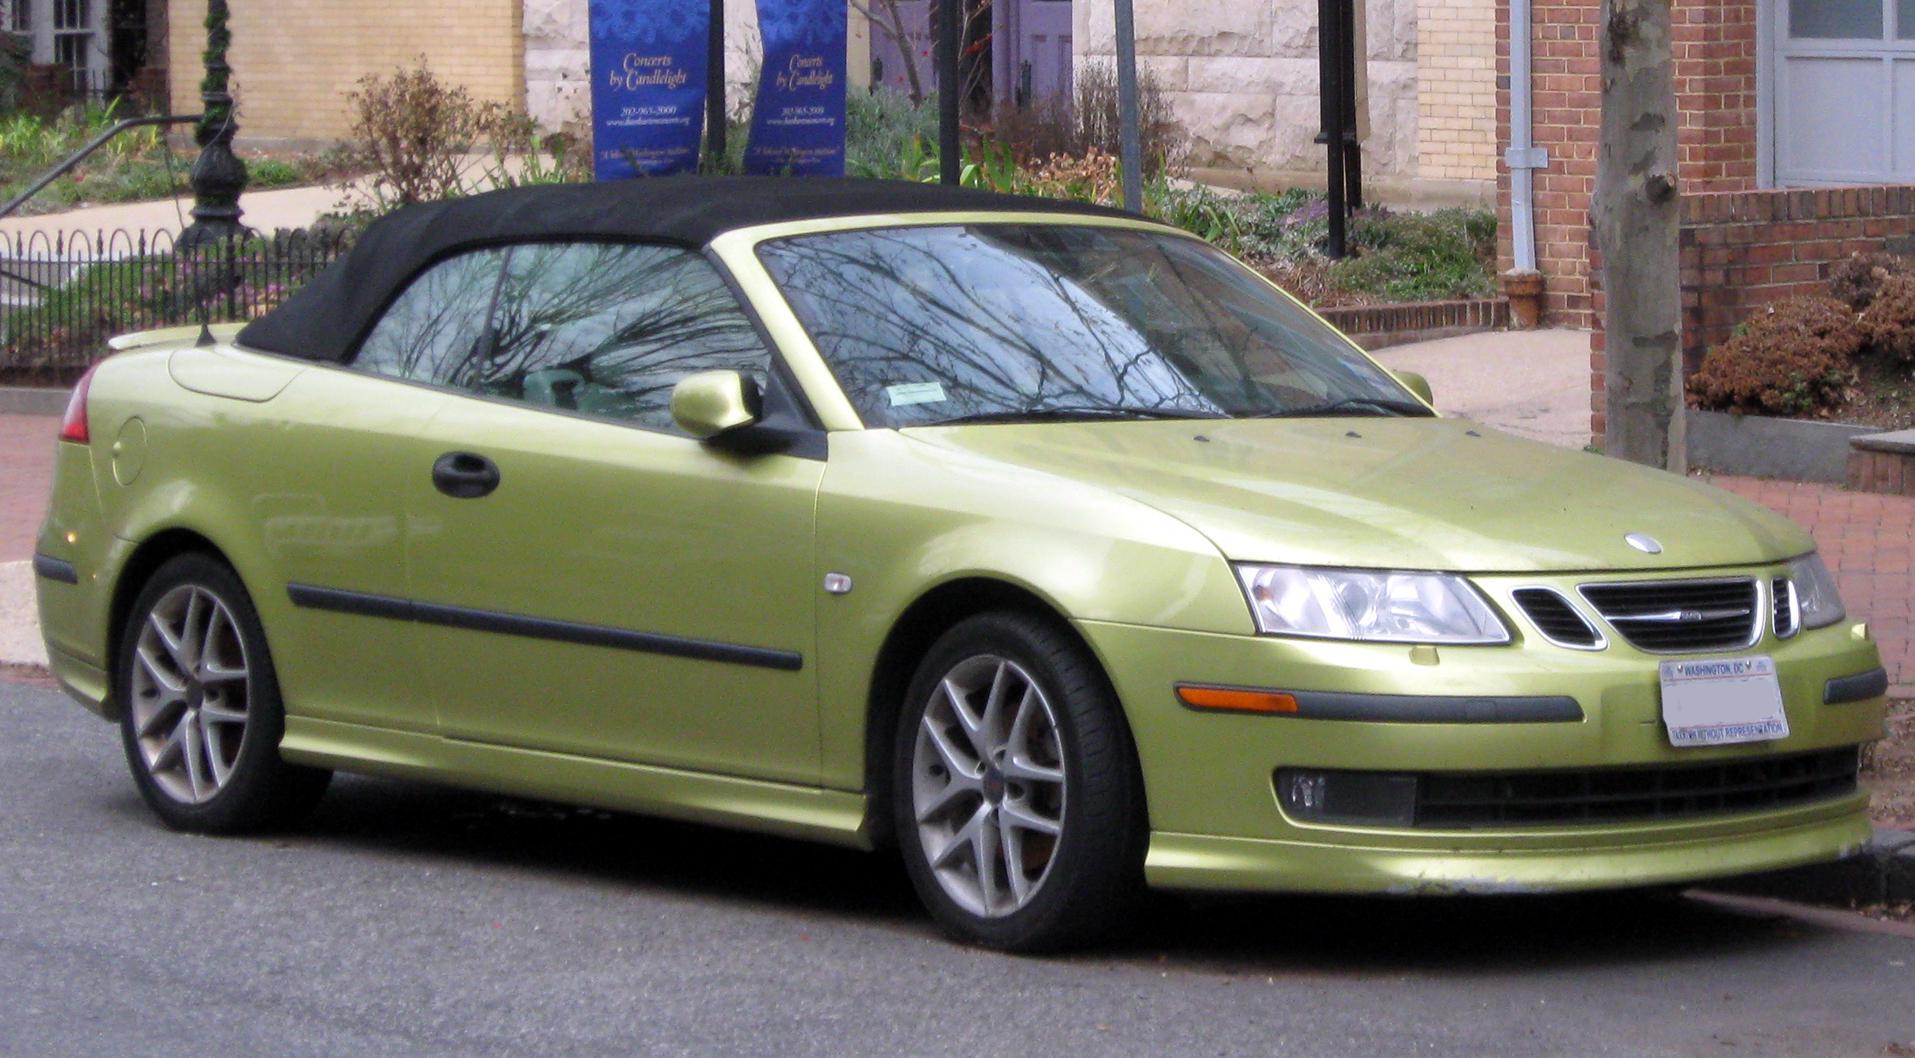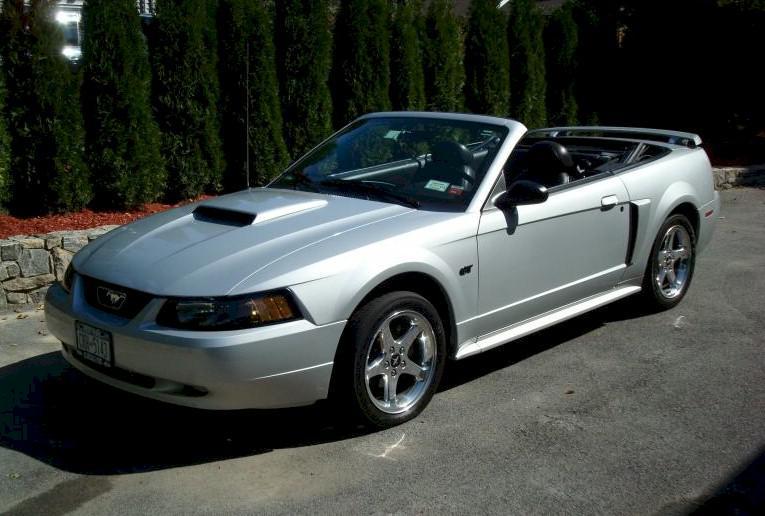The first image is the image on the left, the second image is the image on the right. Examine the images to the left and right. Is the description "The image on the left features a white convertible." accurate? Answer yes or no. No. The first image is the image on the left, the second image is the image on the right. For the images shown, is this caption "All the cars are white." true? Answer yes or no. No. 